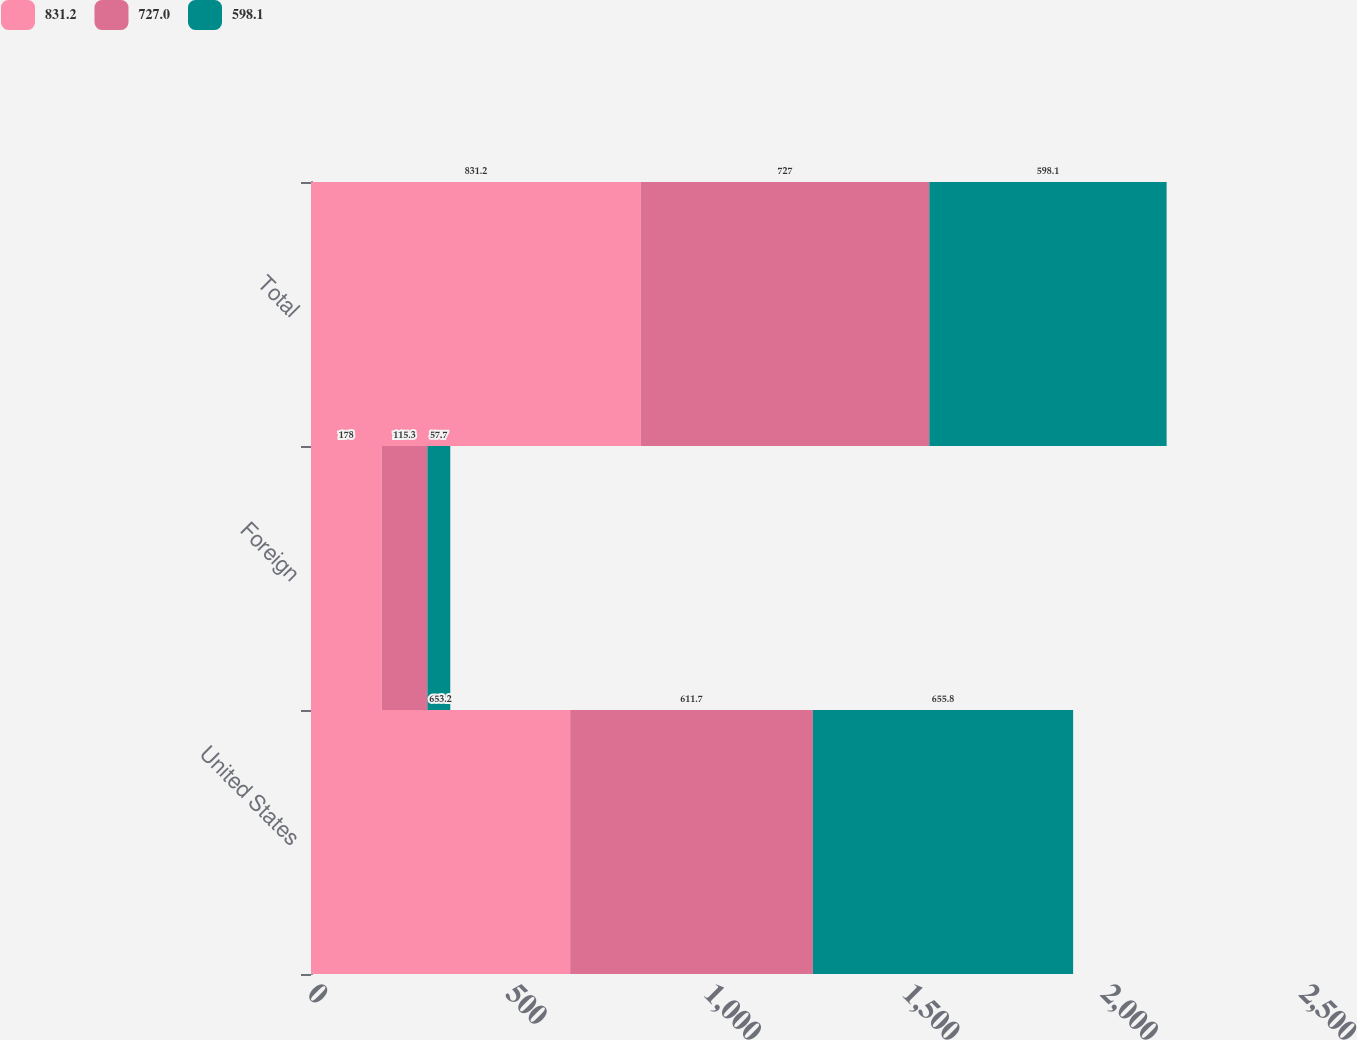Convert chart. <chart><loc_0><loc_0><loc_500><loc_500><stacked_bar_chart><ecel><fcel>United States<fcel>Foreign<fcel>Total<nl><fcel>831.2<fcel>653.2<fcel>178<fcel>831.2<nl><fcel>727<fcel>611.7<fcel>115.3<fcel>727<nl><fcel>598.1<fcel>655.8<fcel>57.7<fcel>598.1<nl></chart> 